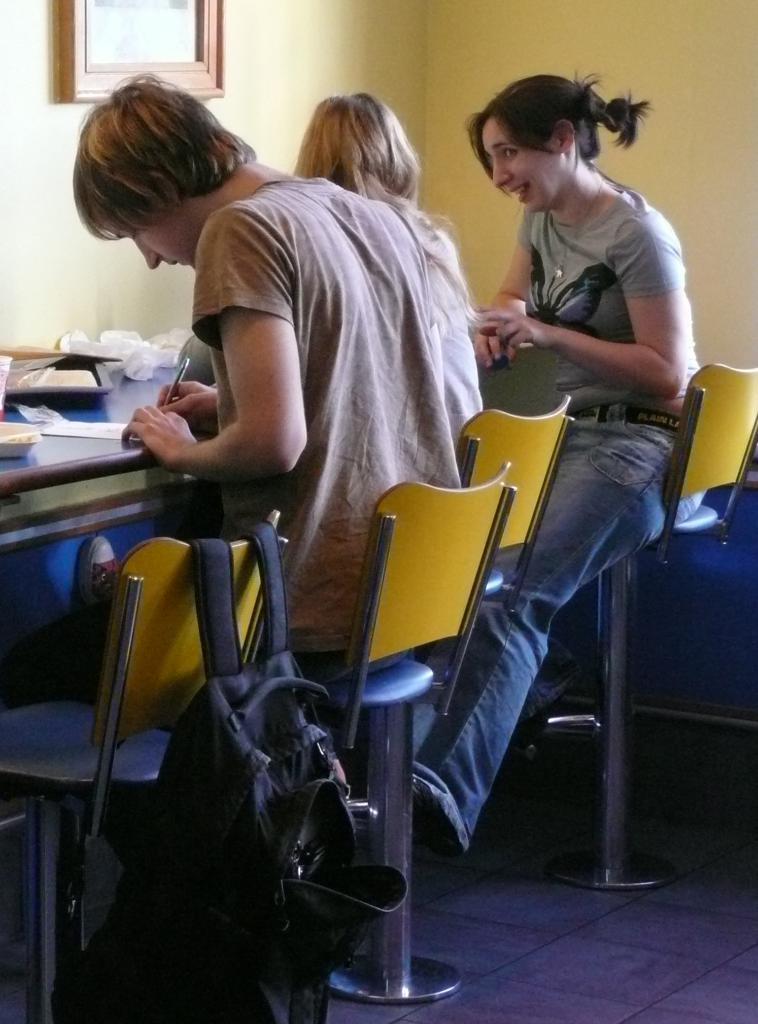How would you summarize this image in a sentence or two? It looks like a classroom,there are total three people in the picture two women and a man,the man is writing something beside him the two women are talking to each other,there is a blue table in front of them,to the left side of the men are there is an empty chair and to that there is a bag,in the background there is a wall,to the wall that is photo frame. 